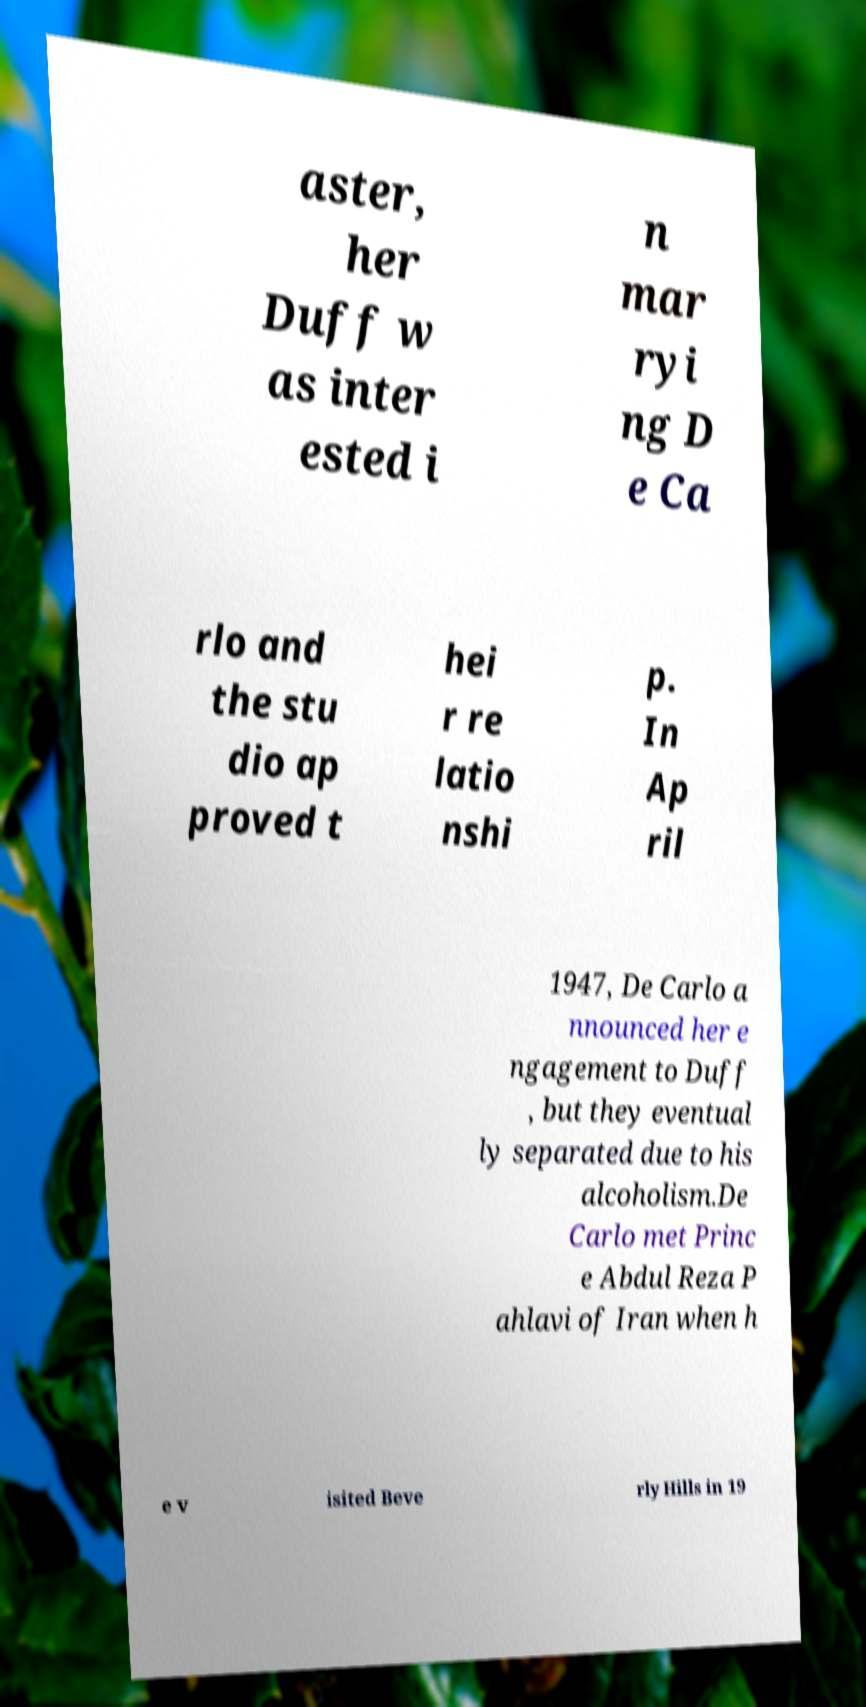What messages or text are displayed in this image? I need them in a readable, typed format. aster, her Duff w as inter ested i n mar ryi ng D e Ca rlo and the stu dio ap proved t hei r re latio nshi p. In Ap ril 1947, De Carlo a nnounced her e ngagement to Duff , but they eventual ly separated due to his alcoholism.De Carlo met Princ e Abdul Reza P ahlavi of Iran when h e v isited Beve rly Hills in 19 